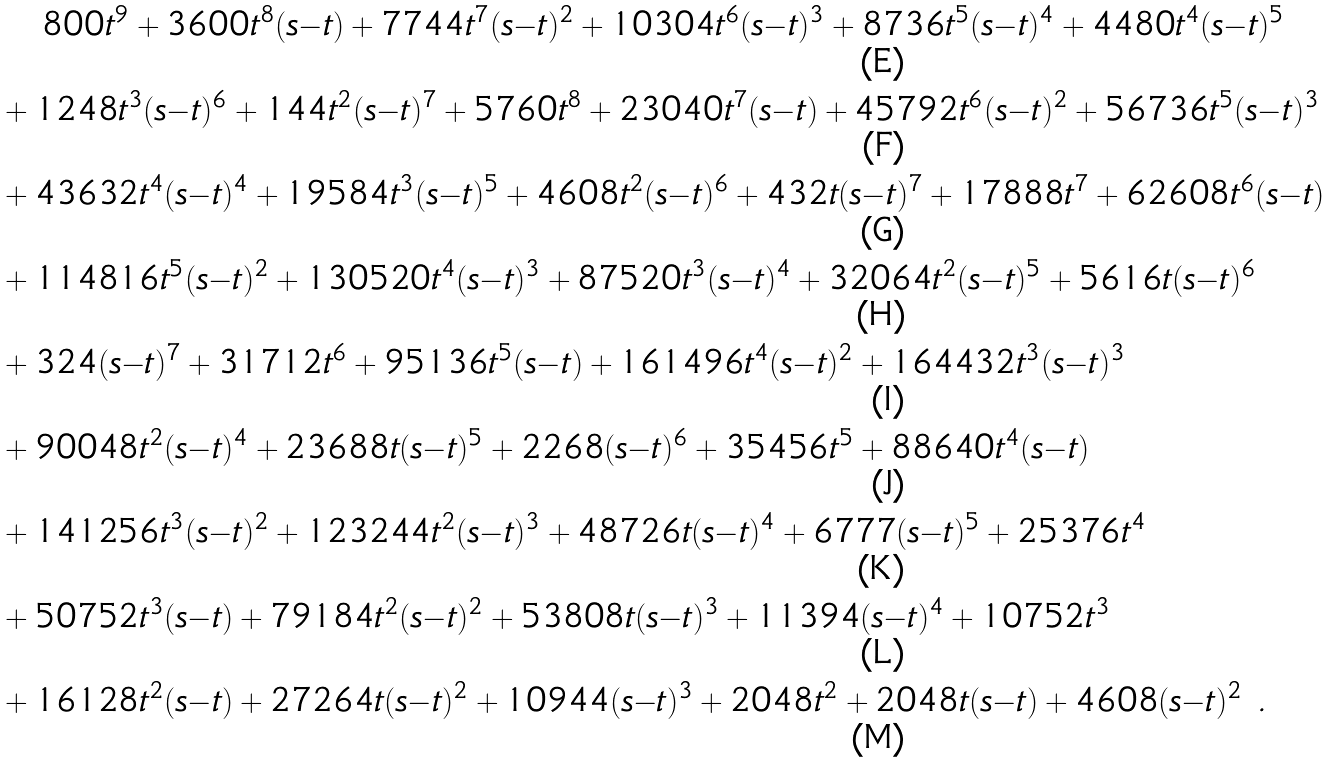<formula> <loc_0><loc_0><loc_500><loc_500>& \quad \, 8 0 0 t ^ { 9 } + 3 6 0 0 t ^ { 8 } ( s { - } t ) + 7 7 4 4 t ^ { 7 } ( s { - } t ) ^ { 2 } + 1 0 3 0 4 t ^ { 6 } ( s { - } t ) ^ { 3 } + 8 7 3 6 t ^ { 5 } ( s { - } t ) ^ { 4 } + 4 4 8 0 t ^ { 4 } ( s { - } t ) ^ { 5 } \\ & + 1 2 4 8 t ^ { 3 } ( s { - } t ) ^ { 6 } + 1 4 4 t ^ { 2 } ( s { - } t ) ^ { 7 } + 5 7 6 0 t ^ { 8 } + 2 3 0 4 0 t ^ { 7 } ( s { - } t ) + 4 5 7 9 2 t ^ { 6 } ( s { - } t ) ^ { 2 } + 5 6 7 3 6 t ^ { 5 } ( s { - } t ) ^ { 3 } \\ & + 4 3 6 3 2 t ^ { 4 } ( s { - } t ) ^ { 4 } + 1 9 5 8 4 t ^ { 3 } ( s { - } t ) ^ { 5 } + 4 6 0 8 t ^ { 2 } ( s { - } t ) ^ { 6 } + 4 3 2 t ( s { - } t ) ^ { 7 } + 1 7 8 8 8 t ^ { 7 } + 6 2 6 0 8 t ^ { 6 } ( s { - } t ) \\ & + 1 1 4 8 1 6 t ^ { 5 } ( s { - } t ) ^ { 2 } + 1 3 0 5 2 0 t ^ { 4 } ( s { - } t ) ^ { 3 } + 8 7 5 2 0 t ^ { 3 } ( s { - } t ) ^ { 4 } + 3 2 0 6 4 t ^ { 2 } ( s { - } t ) ^ { 5 } + 5 6 1 6 t ( s { - } t ) ^ { 6 } \\ & + 3 2 4 ( s { - } t ) ^ { 7 } + 3 1 7 1 2 t ^ { 6 } + 9 5 1 3 6 t ^ { 5 } ( s { - } t ) + 1 6 1 4 9 6 t ^ { 4 } ( s { - } t ) ^ { 2 } + 1 6 4 4 3 2 t ^ { 3 } ( s { - } t ) ^ { 3 } \\ & + 9 0 0 4 8 t ^ { 2 } ( s { - } t ) ^ { 4 } + 2 3 6 8 8 t ( s { - } t ) ^ { 5 } + 2 2 6 8 ( s { - } t ) ^ { 6 } + 3 5 4 5 6 t ^ { 5 } + 8 8 6 4 0 t ^ { 4 } ( s { - } t ) \\ & + 1 4 1 2 5 6 t ^ { 3 } ( s { - } t ) ^ { 2 } + 1 2 3 2 4 4 t ^ { 2 } ( s { - } t ) ^ { 3 } + 4 8 7 2 6 t ( s { - } t ) ^ { 4 } + 6 7 7 7 ( s { - } t ) ^ { 5 } + 2 5 3 7 6 t ^ { 4 } \\ & + 5 0 7 5 2 t ^ { 3 } ( s { - } t ) + 7 9 1 8 4 t ^ { 2 } ( s { - } t ) ^ { 2 } + 5 3 8 0 8 t ( s { - } t ) ^ { 3 } + 1 1 3 9 4 ( s { - } t ) ^ { 4 } + 1 0 7 5 2 t ^ { 3 } \\ & + 1 6 1 2 8 t ^ { 2 } ( s { - } t ) + 2 7 2 6 4 t ( s { - } t ) ^ { 2 } + 1 0 9 4 4 ( s { - } t ) ^ { 3 } + 2 0 4 8 t ^ { 2 } + 2 0 4 8 t ( s { - } t ) + 4 6 0 8 ( s { - } t ) ^ { 2 } \ .</formula> 